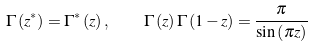<formula> <loc_0><loc_0><loc_500><loc_500>\Gamma \left ( z ^ { \ast } \right ) = \Gamma ^ { \ast } \left ( z \right ) , \quad \Gamma \left ( z \right ) \Gamma \left ( 1 - z \right ) = \frac { \pi } { \sin \left ( \pi z \right ) }</formula> 